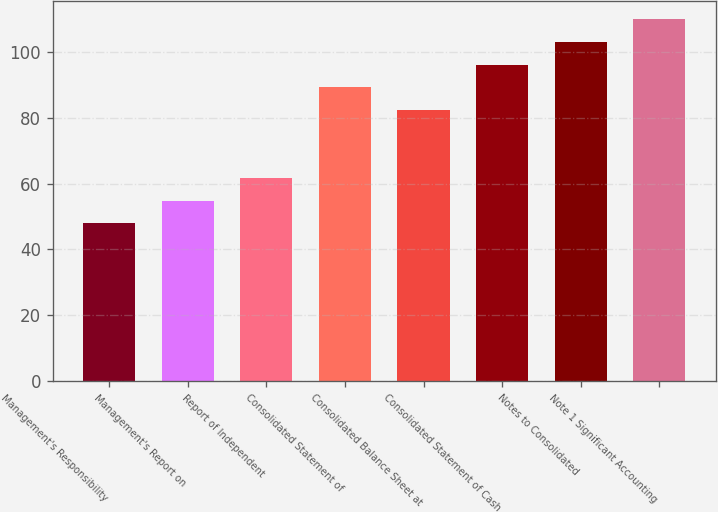Convert chart to OTSL. <chart><loc_0><loc_0><loc_500><loc_500><bar_chart><fcel>Management's Responsibility<fcel>Management's Report on<fcel>Report of Independent<fcel>Consolidated Statement of<fcel>Consolidated Balance Sheet at<fcel>Consolidated Statement of Cash<fcel>Notes to Consolidated<fcel>Note 1 Significant Accounting<nl><fcel>48<fcel>54.9<fcel>61.8<fcel>89.4<fcel>82.5<fcel>96.3<fcel>103.2<fcel>110.1<nl></chart> 